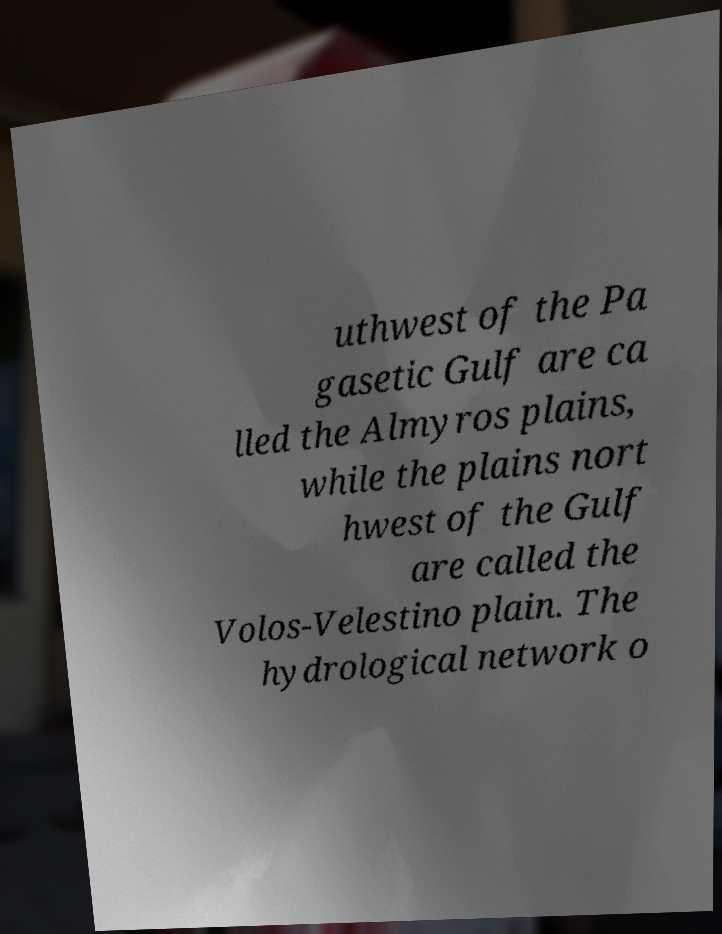For documentation purposes, I need the text within this image transcribed. Could you provide that? uthwest of the Pa gasetic Gulf are ca lled the Almyros plains, while the plains nort hwest of the Gulf are called the Volos-Velestino plain. The hydrological network o 